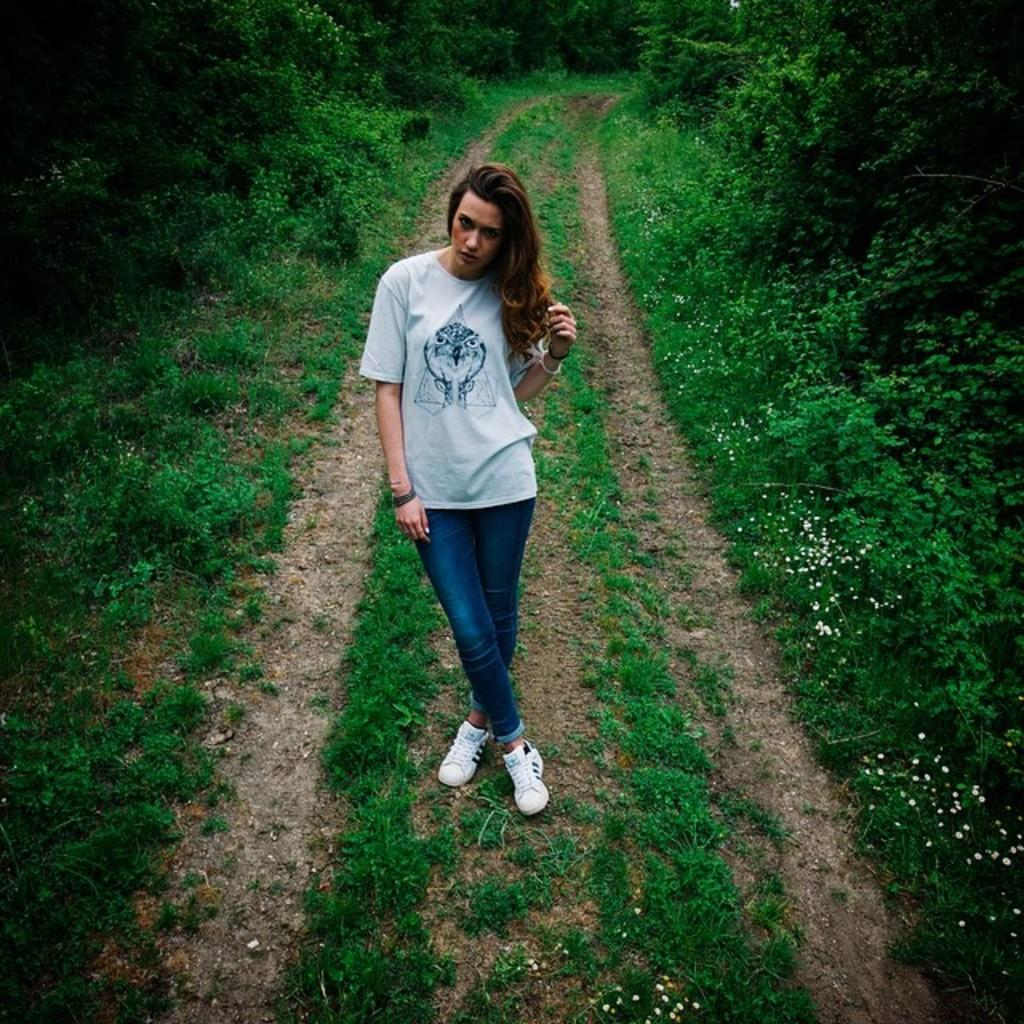Who is the main subject in the image? There is a woman in the image. What is the woman wearing? The woman is wearing a white t-shirt. Where is the woman standing? The woman is standing on a path. What can be seen in the background of the image? There are plants and trees in the background of the image. What book is the woman holding in the image? There is no book present in the image; the woman is not holding anything. 